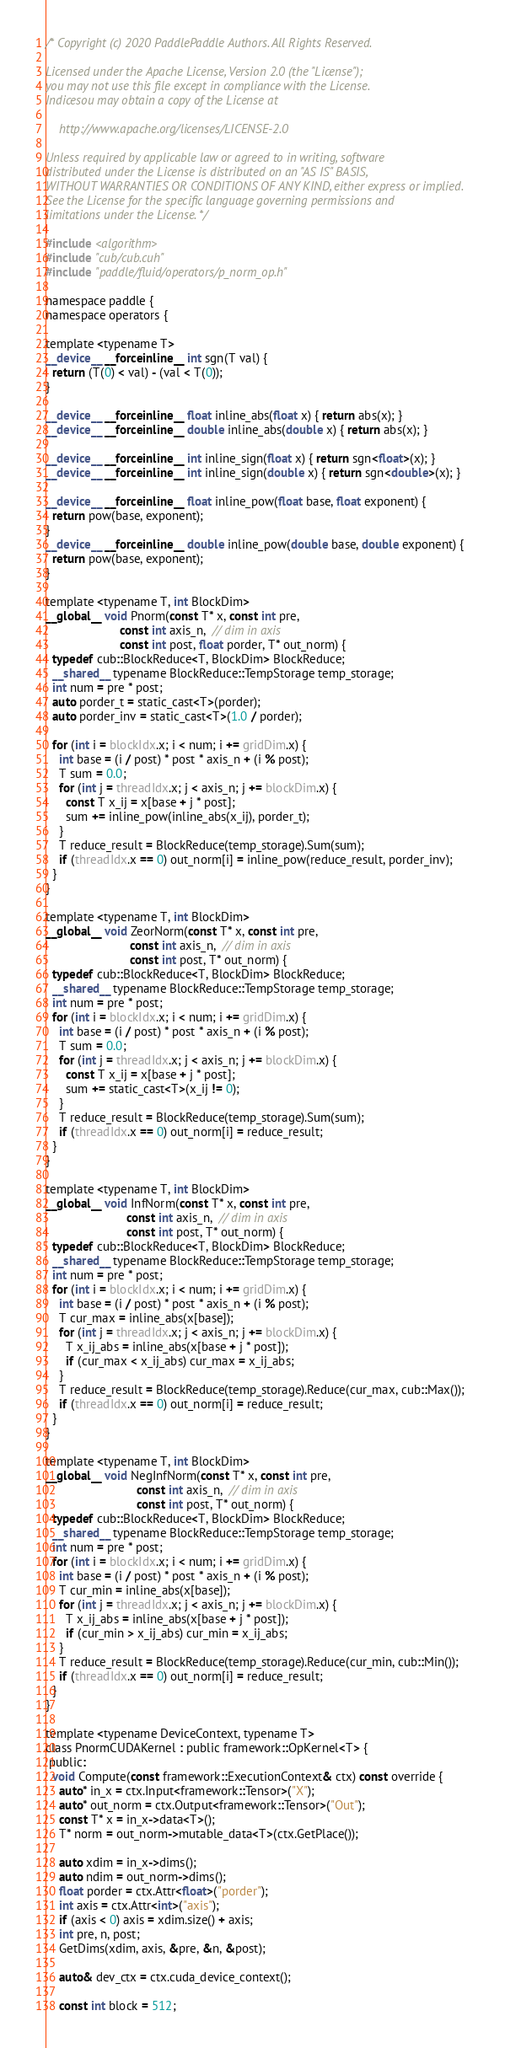<code> <loc_0><loc_0><loc_500><loc_500><_Cuda_>/* Copyright (c) 2020 PaddlePaddle Authors. All Rights Reserved.

Licensed under the Apache License, Version 2.0 (the "License");
you may not use this file except in compliance with the License.
Indicesou may obtain a copy of the License at

    http://www.apache.org/licenses/LICENSE-2.0

Unless required by applicable law or agreed to in writing, software
distributed under the License is distributed on an "AS IS" BASIS,
WITHOUT WARRANTIES OR CONDITIONS OF ANY KIND, either express or implied.
See the License for the specific language governing permissions and
limitations under the License. */

#include <algorithm>
#include "cub/cub.cuh"
#include "paddle/fluid/operators/p_norm_op.h"

namespace paddle {
namespace operators {

template <typename T>
__device__ __forceinline__ int sgn(T val) {
  return (T(0) < val) - (val < T(0));
}

__device__ __forceinline__ float inline_abs(float x) { return abs(x); }
__device__ __forceinline__ double inline_abs(double x) { return abs(x); }

__device__ __forceinline__ int inline_sign(float x) { return sgn<float>(x); }
__device__ __forceinline__ int inline_sign(double x) { return sgn<double>(x); }

__device__ __forceinline__ float inline_pow(float base, float exponent) {
  return pow(base, exponent);
}
__device__ __forceinline__ double inline_pow(double base, double exponent) {
  return pow(base, exponent);
}

template <typename T, int BlockDim>
__global__ void Pnorm(const T* x, const int pre,
                      const int axis_n,  // dim in axis
                      const int post, float porder, T* out_norm) {
  typedef cub::BlockReduce<T, BlockDim> BlockReduce;
  __shared__ typename BlockReduce::TempStorage temp_storage;
  int num = pre * post;
  auto porder_t = static_cast<T>(porder);
  auto porder_inv = static_cast<T>(1.0 / porder);

  for (int i = blockIdx.x; i < num; i += gridDim.x) {
    int base = (i / post) * post * axis_n + (i % post);
    T sum = 0.0;
    for (int j = threadIdx.x; j < axis_n; j += blockDim.x) {
      const T x_ij = x[base + j * post];
      sum += inline_pow(inline_abs(x_ij), porder_t);
    }
    T reduce_result = BlockReduce(temp_storage).Sum(sum);
    if (threadIdx.x == 0) out_norm[i] = inline_pow(reduce_result, porder_inv);
  }
}

template <typename T, int BlockDim>
__global__ void ZeorNorm(const T* x, const int pre,
                         const int axis_n,  // dim in axis
                         const int post, T* out_norm) {
  typedef cub::BlockReduce<T, BlockDim> BlockReduce;
  __shared__ typename BlockReduce::TempStorage temp_storage;
  int num = pre * post;
  for (int i = blockIdx.x; i < num; i += gridDim.x) {
    int base = (i / post) * post * axis_n + (i % post);
    T sum = 0.0;
    for (int j = threadIdx.x; j < axis_n; j += blockDim.x) {
      const T x_ij = x[base + j * post];
      sum += static_cast<T>(x_ij != 0);
    }
    T reduce_result = BlockReduce(temp_storage).Sum(sum);
    if (threadIdx.x == 0) out_norm[i] = reduce_result;
  }
}

template <typename T, int BlockDim>
__global__ void InfNorm(const T* x, const int pre,
                        const int axis_n,  // dim in axis
                        const int post, T* out_norm) {
  typedef cub::BlockReduce<T, BlockDim> BlockReduce;
  __shared__ typename BlockReduce::TempStorage temp_storage;
  int num = pre * post;
  for (int i = blockIdx.x; i < num; i += gridDim.x) {
    int base = (i / post) * post * axis_n + (i % post);
    T cur_max = inline_abs(x[base]);
    for (int j = threadIdx.x; j < axis_n; j += blockDim.x) {
      T x_ij_abs = inline_abs(x[base + j * post]);
      if (cur_max < x_ij_abs) cur_max = x_ij_abs;
    }
    T reduce_result = BlockReduce(temp_storage).Reduce(cur_max, cub::Max());
    if (threadIdx.x == 0) out_norm[i] = reduce_result;
  }
}

template <typename T, int BlockDim>
__global__ void NegInfNorm(const T* x, const int pre,
                           const int axis_n,  // dim in axis
                           const int post, T* out_norm) {
  typedef cub::BlockReduce<T, BlockDim> BlockReduce;
  __shared__ typename BlockReduce::TempStorage temp_storage;
  int num = pre * post;
  for (int i = blockIdx.x; i < num; i += gridDim.x) {
    int base = (i / post) * post * axis_n + (i % post);
    T cur_min = inline_abs(x[base]);
    for (int j = threadIdx.x; j < axis_n; j += blockDim.x) {
      T x_ij_abs = inline_abs(x[base + j * post]);
      if (cur_min > x_ij_abs) cur_min = x_ij_abs;
    }
    T reduce_result = BlockReduce(temp_storage).Reduce(cur_min, cub::Min());
    if (threadIdx.x == 0) out_norm[i] = reduce_result;
  }
}

template <typename DeviceContext, typename T>
class PnormCUDAKernel : public framework::OpKernel<T> {
 public:
  void Compute(const framework::ExecutionContext& ctx) const override {
    auto* in_x = ctx.Input<framework::Tensor>("X");
    auto* out_norm = ctx.Output<framework::Tensor>("Out");
    const T* x = in_x->data<T>();
    T* norm = out_norm->mutable_data<T>(ctx.GetPlace());

    auto xdim = in_x->dims();
    auto ndim = out_norm->dims();
    float porder = ctx.Attr<float>("porder");
    int axis = ctx.Attr<int>("axis");
    if (axis < 0) axis = xdim.size() + axis;
    int pre, n, post;
    GetDims(xdim, axis, &pre, &n, &post);

    auto& dev_ctx = ctx.cuda_device_context();

    const int block = 512;</code> 